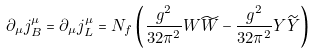<formula> <loc_0><loc_0><loc_500><loc_500>\partial _ { \mu } j _ { B } ^ { \mu } = \partial _ { \mu } j _ { L } ^ { \mu } = N _ { f } \left ( \frac { g ^ { 2 } } { 3 2 \pi ^ { 2 } } W \widetilde { W } - \frac { g ^ { 2 } } { 3 2 \pi ^ { 2 } } Y \widetilde { Y } \right )</formula> 